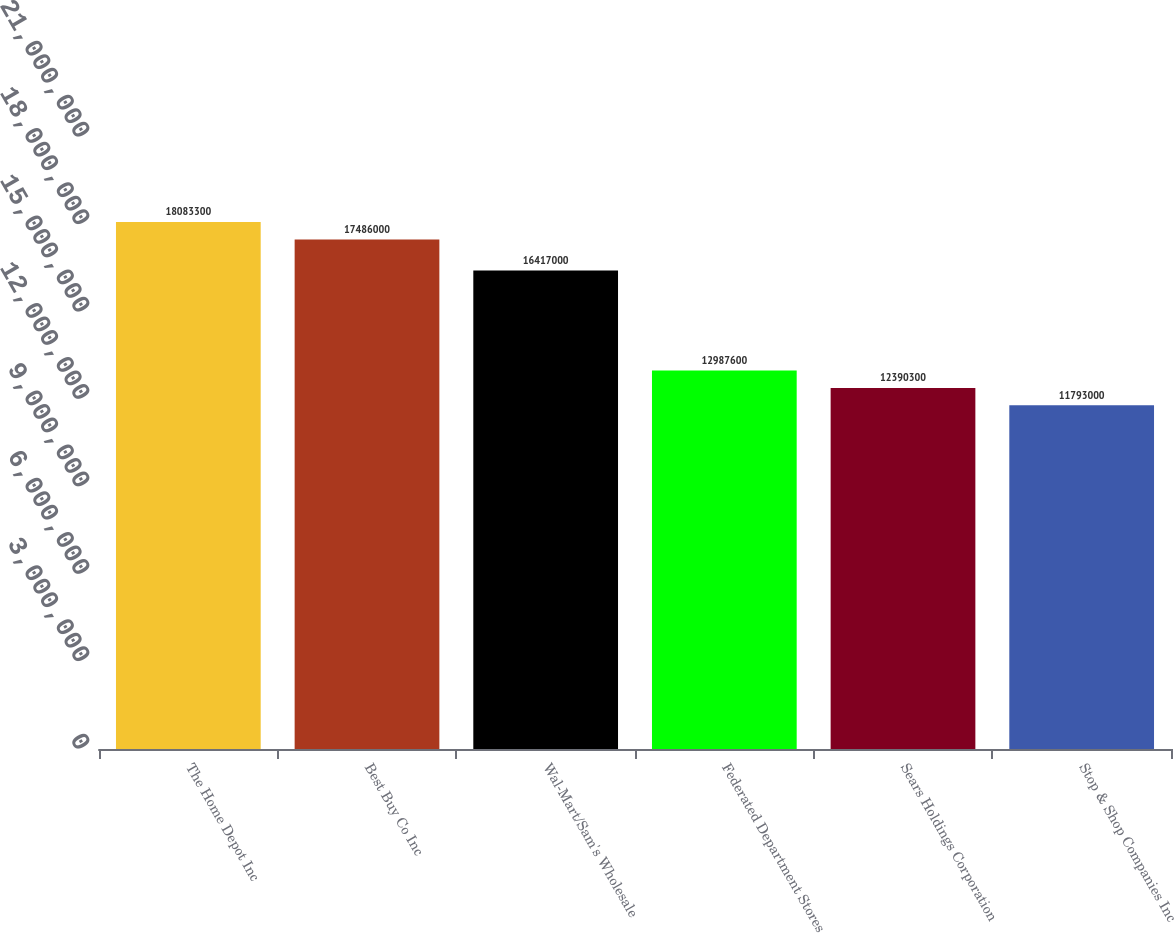Convert chart to OTSL. <chart><loc_0><loc_0><loc_500><loc_500><bar_chart><fcel>The Home Depot Inc<fcel>Best Buy Co Inc<fcel>Wal-Mart/Sam's Wholesale<fcel>Federated Department Stores<fcel>Sears Holdings Corporation<fcel>Stop & Shop Companies Inc<nl><fcel>1.80833e+07<fcel>1.7486e+07<fcel>1.6417e+07<fcel>1.29876e+07<fcel>1.23903e+07<fcel>1.1793e+07<nl></chart> 